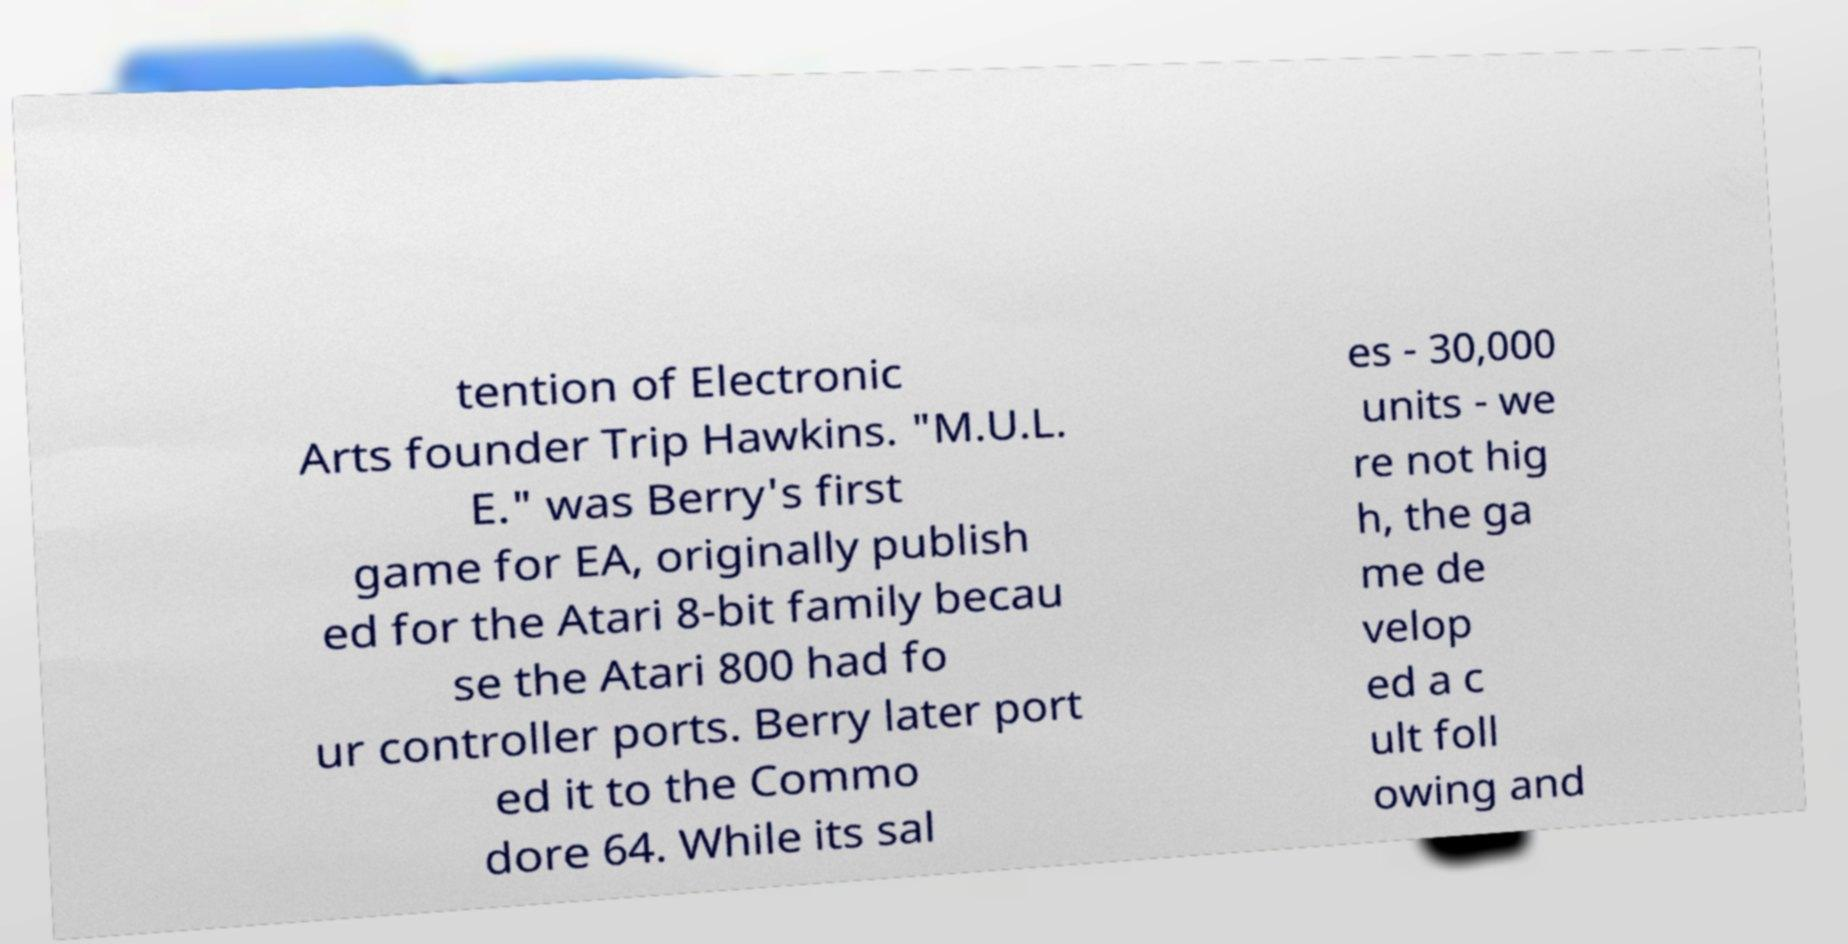There's text embedded in this image that I need extracted. Can you transcribe it verbatim? tention of Electronic Arts founder Trip Hawkins. "M.U.L. E." was Berry's first game for EA, originally publish ed for the Atari 8-bit family becau se the Atari 800 had fo ur controller ports. Berry later port ed it to the Commo dore 64. While its sal es - 30,000 units - we re not hig h, the ga me de velop ed a c ult foll owing and 